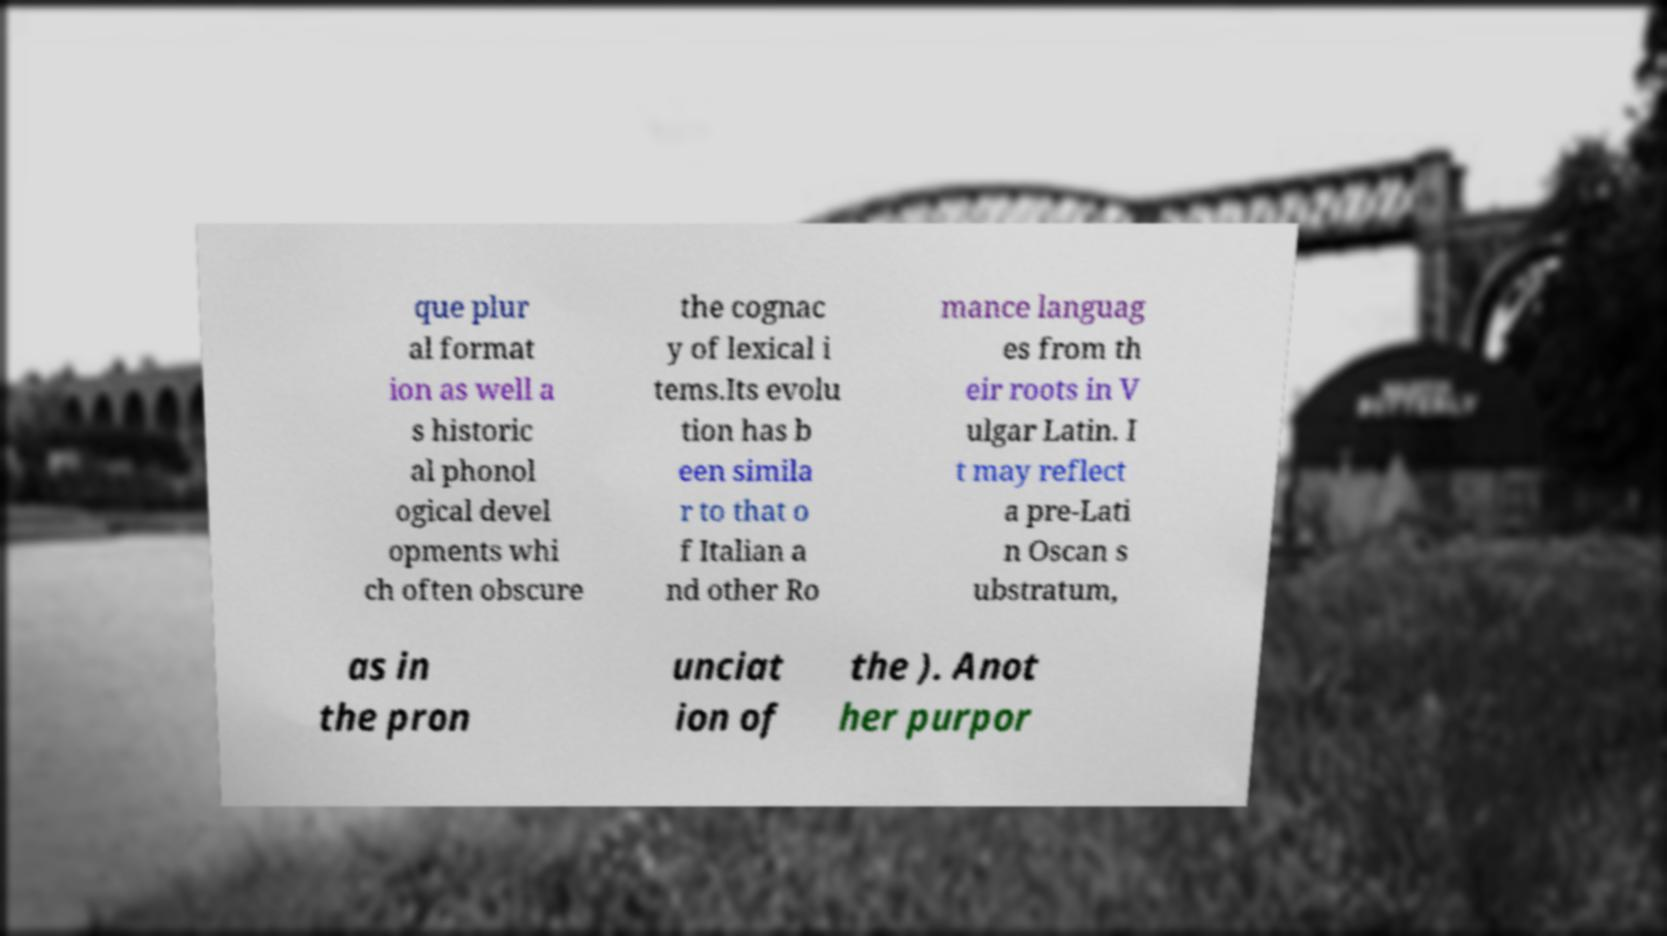Please identify and transcribe the text found in this image. que plur al format ion as well a s historic al phonol ogical devel opments whi ch often obscure the cognac y of lexical i tems.Its evolu tion has b een simila r to that o f Italian a nd other Ro mance languag es from th eir roots in V ulgar Latin. I t may reflect a pre-Lati n Oscan s ubstratum, as in the pron unciat ion of the ). Anot her purpor 